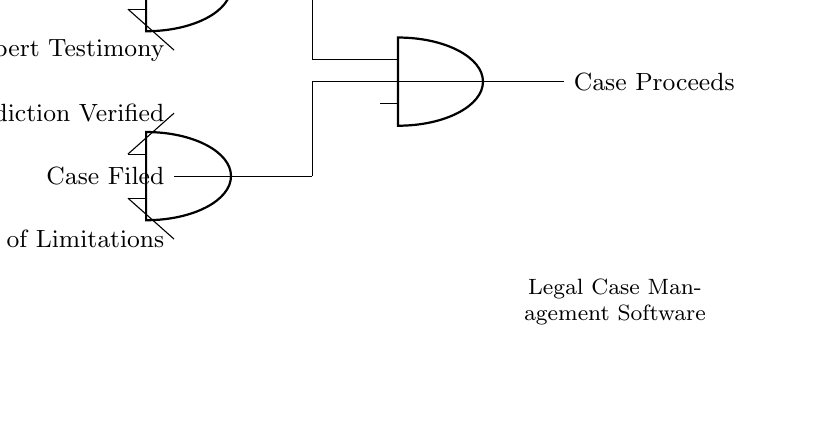What are the inputs to the first AND gate? The first AND gate takes two inputs: "Jurisdiction Verified" and "Statute of Limitations." These inputs are represented as the lines feeding into the first AND gate in the circuit diagram.
Answer: Jurisdiction Verified, Statute of Limitations What is the output of the final AND gate? The output of the final AND gate is "Case Proceeds." This is the result of having all the necessary conditions verified through the preceding AND gates feeding into it.
Answer: Case Proceeds How many AND gates are used in the circuit? The circuit has a total of three AND gates: two initial gates and one final gate that outputs the result based on the other two.
Answer: Three What are the necessary conditions for the case to proceed? For the case to proceed, the conditions that must be met are: "Case Filed," "Jurisdiction Verified," "Statute of Limitations," "Evidence Submitted," "Witness Statements," and "Expert Testimony." All of these inputs must be satisfied to produce the output.
Answer: All the above conditions What will happen if one of the inputs to the first AND gate is not met? If either input to the first AND gate ("Jurisdiction Verified" or "Statute of Limitations") is not met, the output of that gate will be zero, which will prevent the final output ("Case Proceeds") from being true, indicating the case cannot proceed.
Answer: The case will not proceed How many total conditions must be verified for the case to proceed? The total number of conditions that must be verified for the case to proceed is six, as outlined by the inputs given at each gate level in the circuit.
Answer: Six 